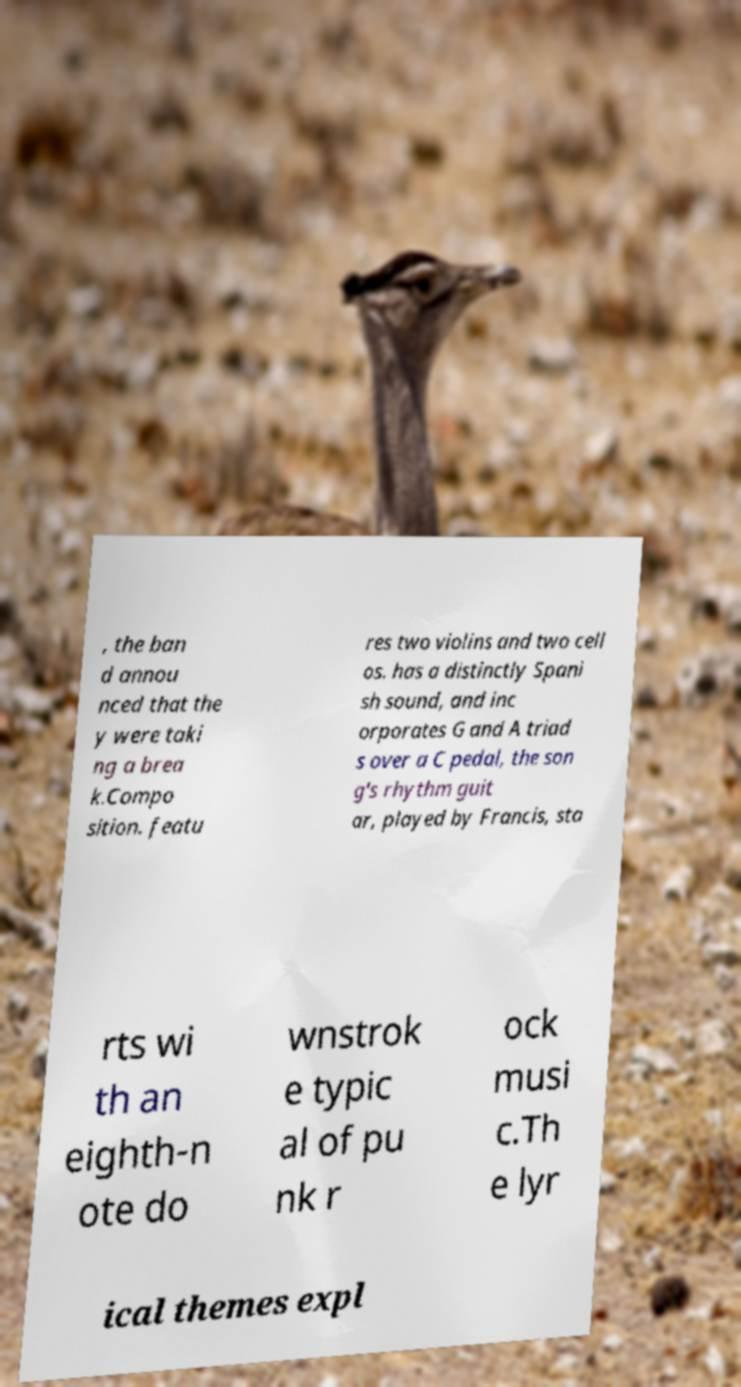There's text embedded in this image that I need extracted. Can you transcribe it verbatim? , the ban d annou nced that the y were taki ng a brea k.Compo sition. featu res two violins and two cell os. has a distinctly Spani sh sound, and inc orporates G and A triad s over a C pedal, the son g's rhythm guit ar, played by Francis, sta rts wi th an eighth-n ote do wnstrok e typic al of pu nk r ock musi c.Th e lyr ical themes expl 